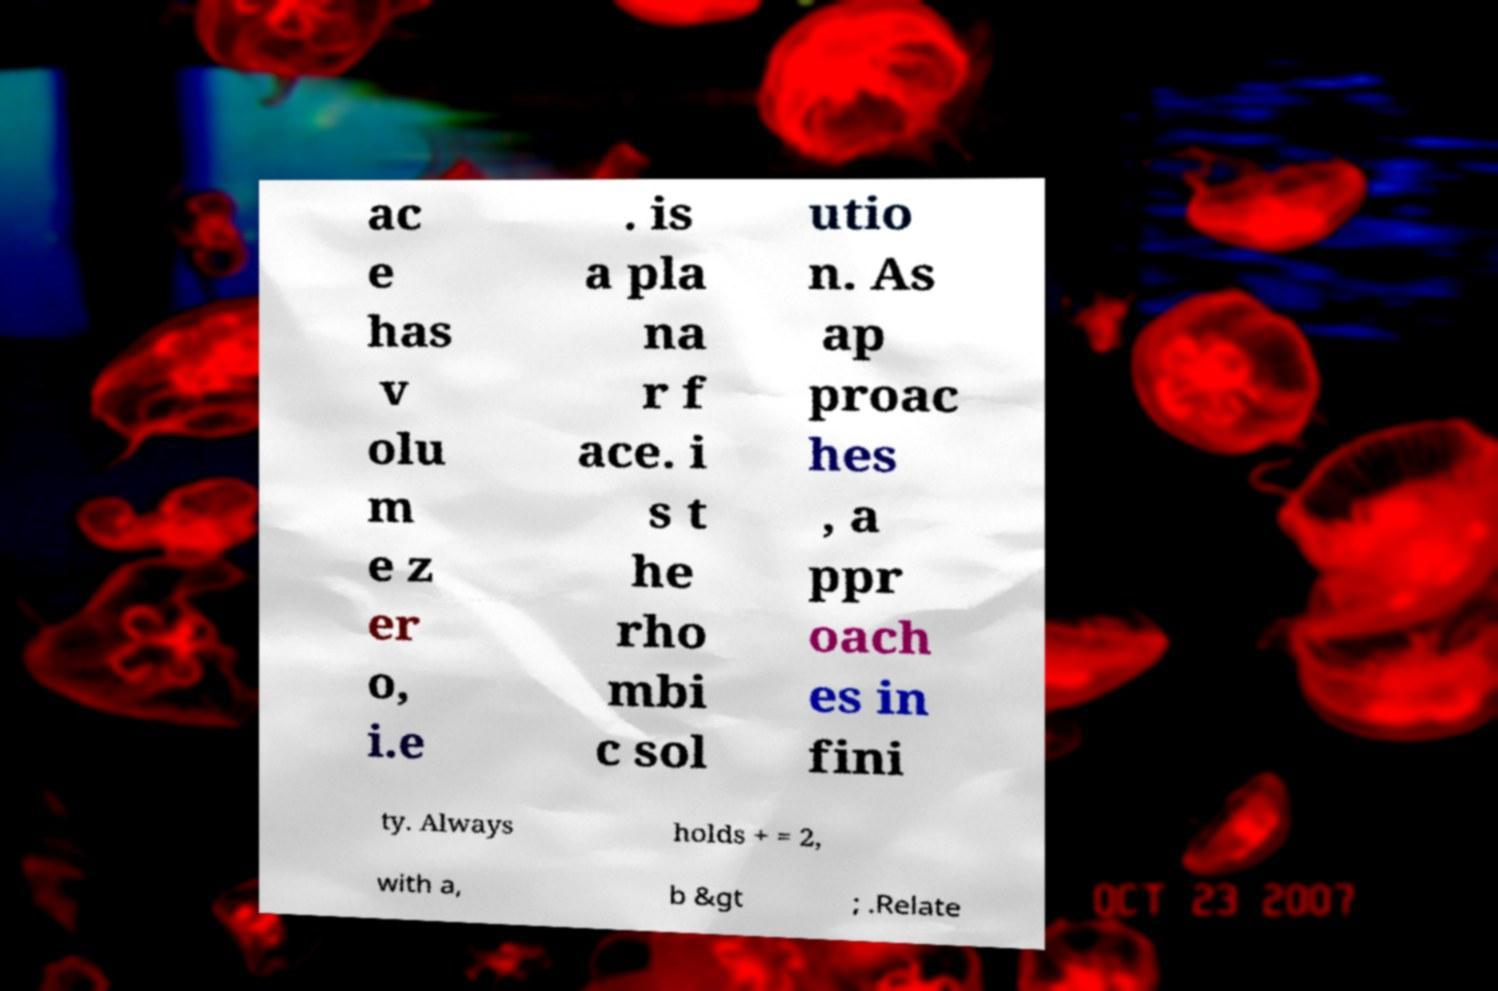Could you extract and type out the text from this image? ac e has v olu m e z er o, i.e . is a pla na r f ace. i s t he rho mbi c sol utio n. As ap proac hes , a ppr oach es in fini ty. Always holds + = 2, with a, b &gt ; .Relate 